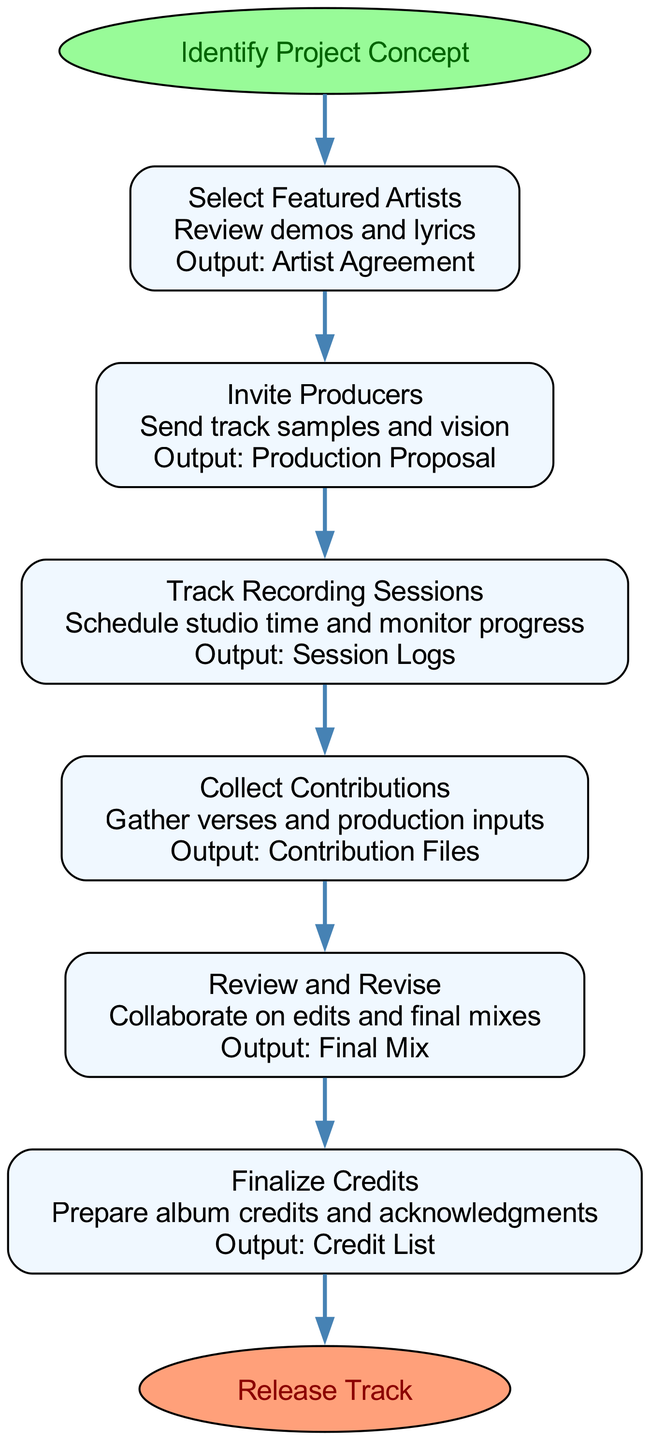What is the first step in the collaboration workflow? The diagram indicates that the first step in the collaboration workflow is "Select Featured Artists." This is derived from the ordering of the steps starting from "Start" to the first step connected to it.
Answer: Select Featured Artists How many steps are there in the collaboration workflow? By counting the defined steps in the diagram, there are six steps listed under the collaboration workflow before reaching the end node.
Answer: Six What is the output of the "Collect Contributions" step? The output labeled in the diagram for the "Collect Contributions" step clearly states "Contribution Files." This is presented in the corresponding box detailing the action and output.
Answer: Contribution Files Which step comes after "Invite Producers"? Following the flow of the diagram, after "Invite Producers," the next step indicated is "Track Recording Sessions." This involves examining the connections between the steps in the workflow.
Answer: Track Recording Sessions What is the final output of the collaboration workflow? The endpoint of the workflow is the "Release Track," which is shown at the end of the diagram. This is reached after all previous steps have been completed, culminating in this final output.
Answer: Release Track What action is associated with the "Review and Revise" step? The action linked to the "Review and Revise" step is "Collaborate on edits and final mixes." This is specified in the corresponding box as part of the step description.
Answer: Collaborate on edits and final mixes How does "Select Featured Artists" relate to "Finalize Credits"? "Select Featured Artists" is the first step while "Finalize Credits" is the last step before reaching the end of the workflow. The relationship is a direct progression indicating that selecting artists is initial to completing the credits.
Answer: Direct progression What is the main purpose of the "Track Recording Sessions" step? The purpose of the "Track Recording Sessions" step is to "Schedule studio time and monitor progress," which indicates its role in ensuring organized recording processes.
Answer: Schedule studio time and monitor progress 